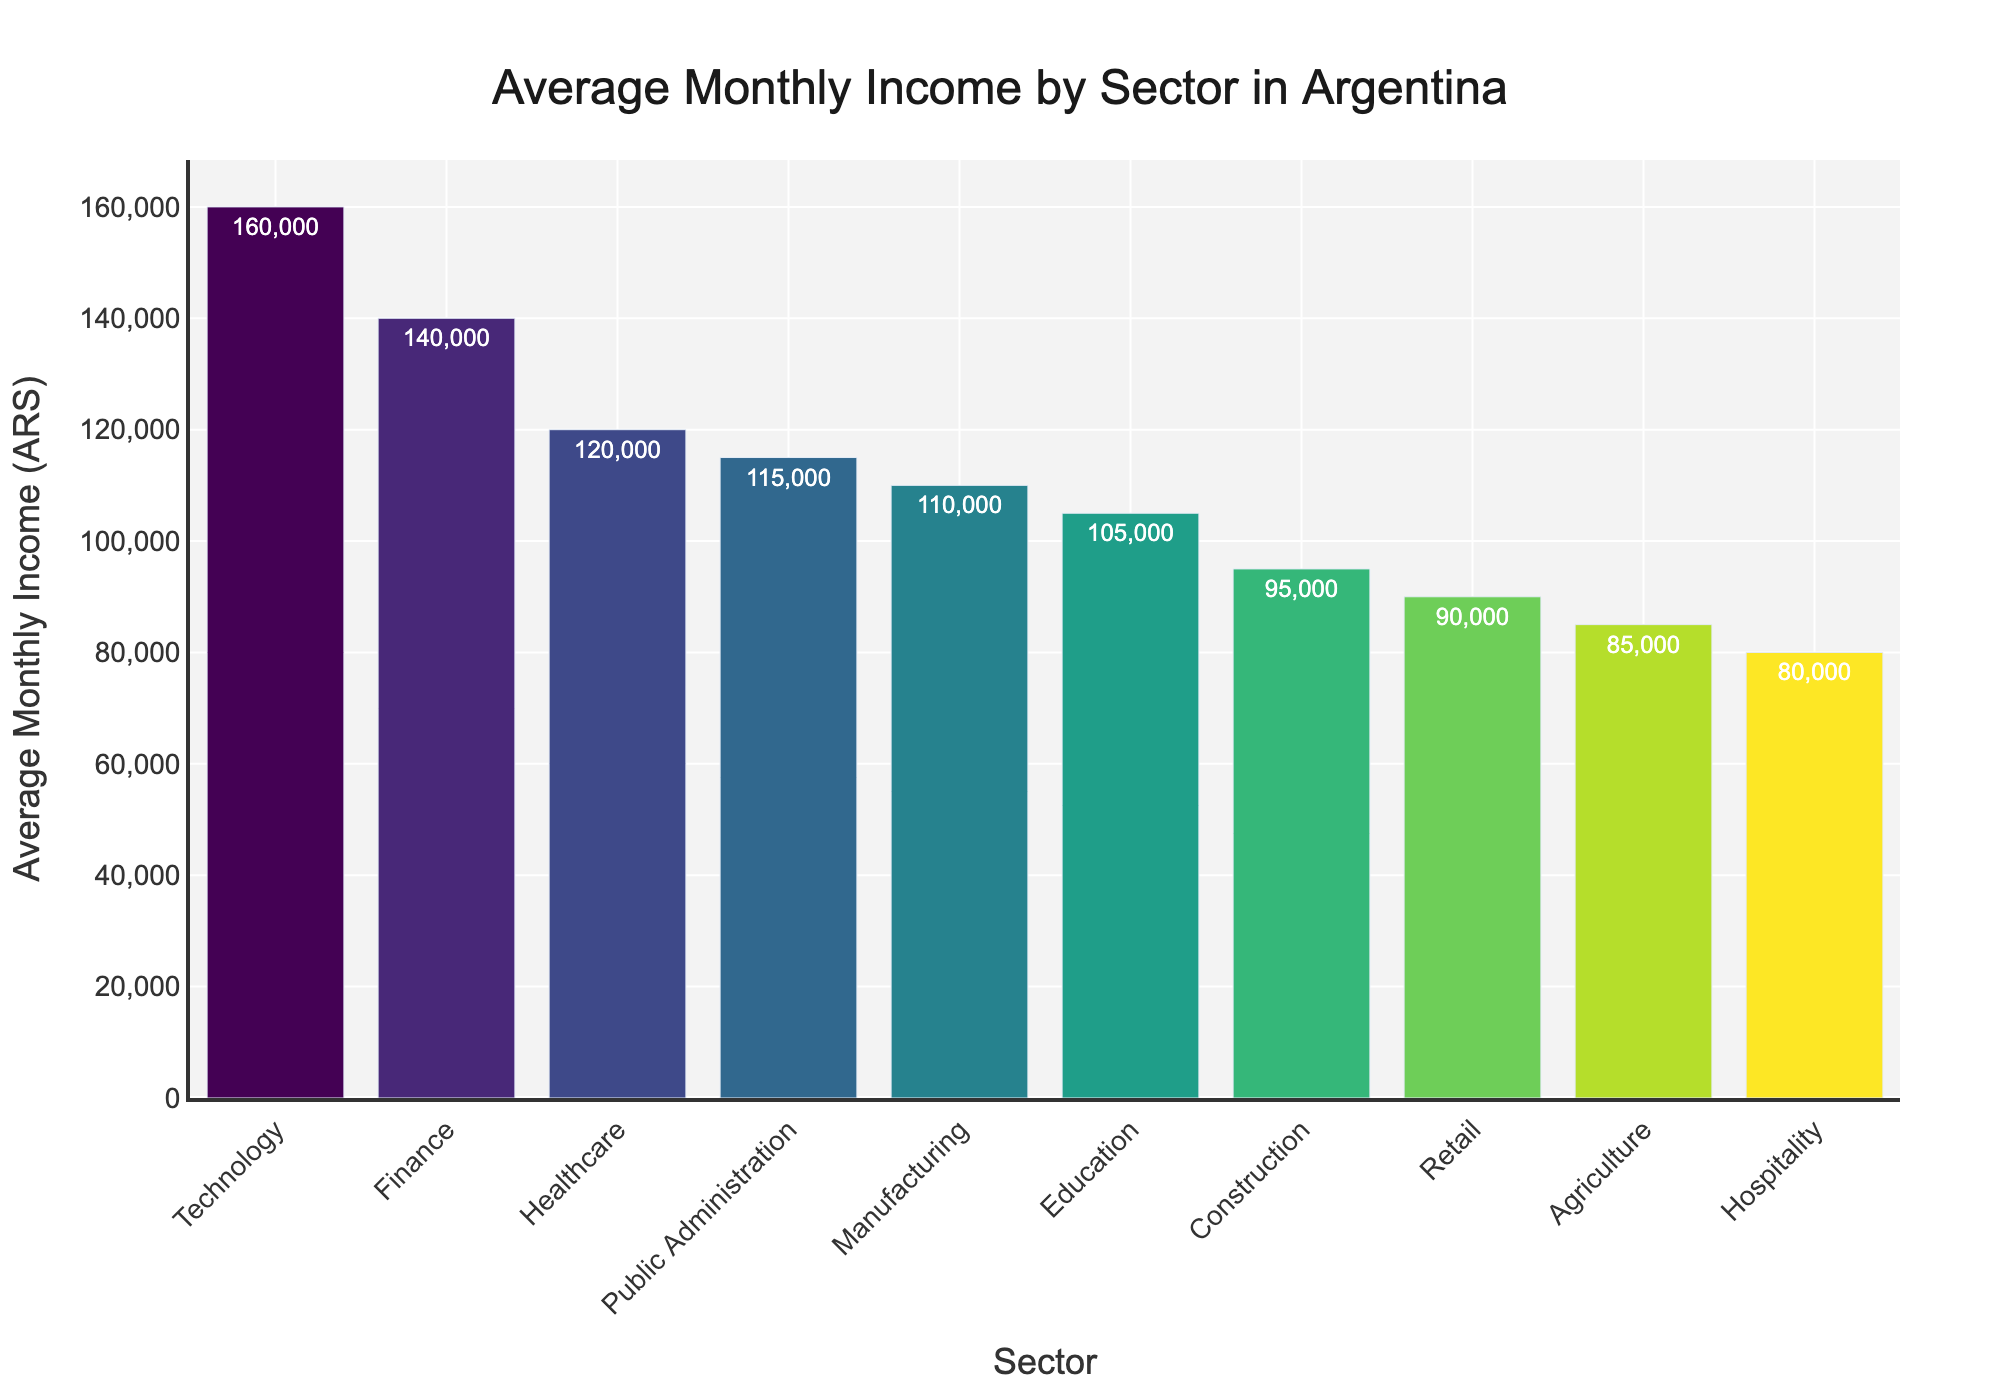Which sector has the highest average monthly income? The bar chart shows that the Technology sector has the tallest bar, indicating it has the highest average monthly income compared to other sectors.
Answer: Technology How much higher is the average monthly income in Healthcare compared to Agriculture? First, locate the average monthly income for Healthcare (120,000 ARS) and Agriculture (85,000 ARS) sectors. Subtract the average income in Agriculture from Healthcare: 120,000 - 85,000 = 35,000.
Answer: 35,000 ARS What is the average income difference between the Finance and Retail sectors? Identify the average monthly income for Finance (140,000 ARS) and Retail (90,000 ARS) sectors. Then subtract the Retail income from the Finance income: 140,000 - 90,000 = 50,000.
Answer: 50,000 ARS Which sector has the lowest average monthly income, and what is that income? Look for the shortest bar in the chart, which represents the Hospitality sector. The income value next to this bar is 80,000 ARS.
Answer: Hospitality, 80,000 ARS What is the cumulative average monthly income of the sectors: Education, Healthcare, and Public Administration? Sum the average monthly incomes of the three sectors: Education (105,000 ARS), Healthcare (120,000 ARS), and Public Administration (115,000 ARS). 105,000 + 120,000 + 115,000 = 340,000.
Answer: 340,000 ARS Which sectors have an average monthly income greater than 100,000 ARS? Identify sectors from the chart whose bars have average monthly incomes above 100,000 ARS. These are Education (105,000), Healthcare (120,000), Finance (140,000), Technology (160,000), and Public Administration (115,000).
Answer: Education, Healthcare, Finance, Technology, Public Administration How much more does an average worker earn in the Technology sector compared to the Agriculture sector? Identify and subtract the average monthly incomes of the Agriculture (85,000 ARS) and Technology (160,000 ARS) sectors. 160,000 - 85,000 = 75,000.
Answer: 75,000 ARS Between Manufacturing and Construction, which sector has a higher average monthly income and by how much? Compare the heights of the bars for the Manufacturing (110,000 ARS) and Construction (95,000 ARS) sectors. Manufacturing has a higher income. Subtract Construction from Manufacturing: 110,000 - 95,000 = 15,000.
Answer: Manufacturing, 15,000 ARS What is the median value of the average monthly incomes across all sectors? Arrange all average monthly incomes in ascending order: 80,000, 85,000, 90,000, 95,000, 105,000, 110,000, 115,000, 120,000, 140,000, 160,000. Find the middle value of this list, the median is 107,500 ARS.
Answer: 107,500 ARS 